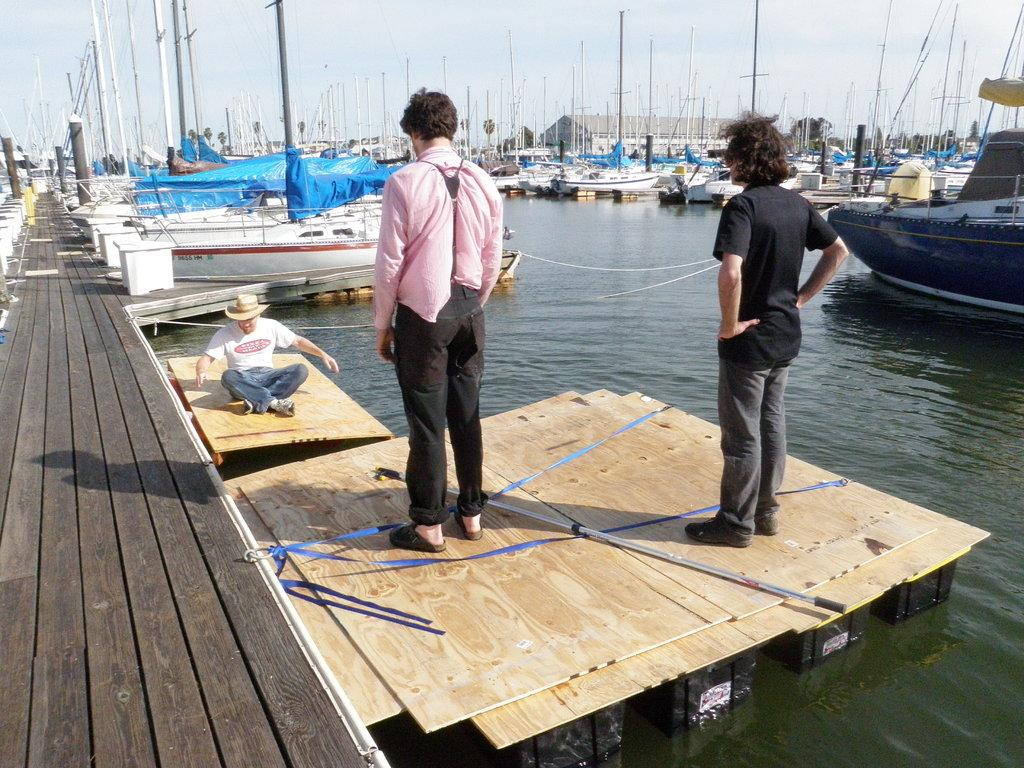How many people are in the image? There are two men in the image. Where are the men standing? The men are standing on a port harbor. What can be seen in the background of the image? There are white color boats and iron pipes in the background. What is the condition of the zinc in the image? There is no zinc present in the image. Is the square visible in the image? There is no square mentioned or visible in the image. 